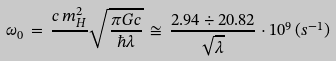Convert formula to latex. <formula><loc_0><loc_0><loc_500><loc_500>\omega _ { 0 } \, = \, \frac { c \, m _ { H } ^ { 2 } } { } \sqrt { \frac { \pi G c } { \hbar { \lambda } } } \, \cong \, \frac { 2 . 9 4 \div 2 0 . 8 2 } { \sqrt { \lambda } } \cdot 1 0 ^ { 9 } \, ( s ^ { - 1 } )</formula> 